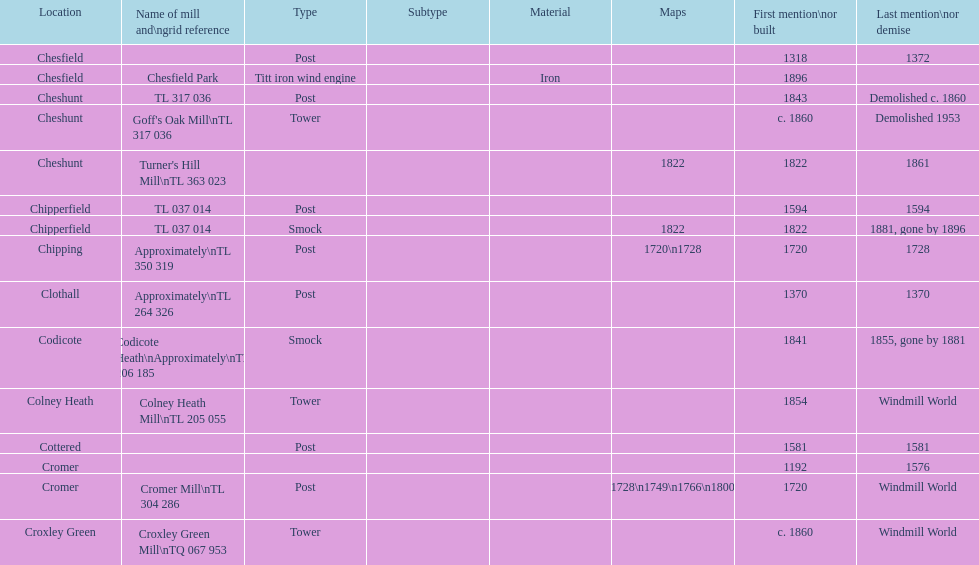What is the total number of mills named cheshunt? 3. 